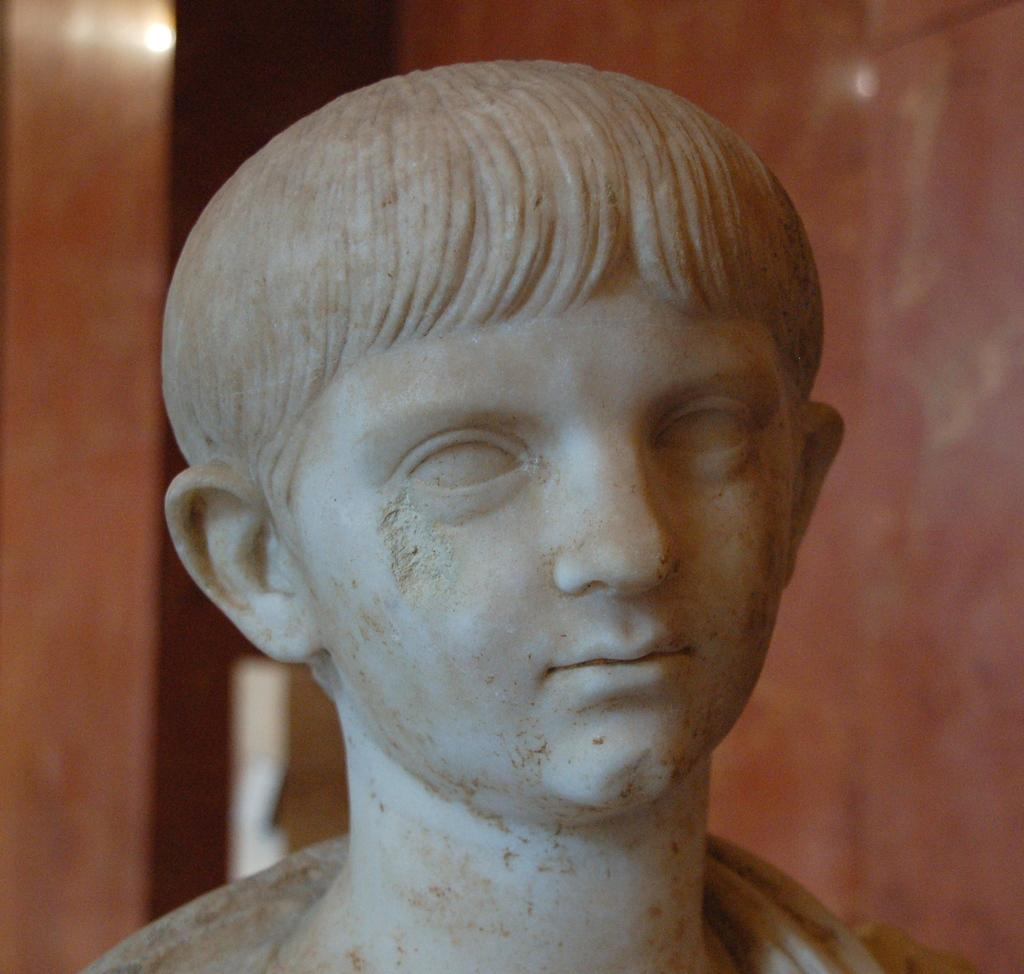What is the main subject in the image? There is a person statue in the image. Can you describe the setting of the image? There is a wall in the background of the image. How many thumbs can be seen on the person statue in the image? There are no thumbs visible on the person statue in the image, as it is a statue and not a living person. 